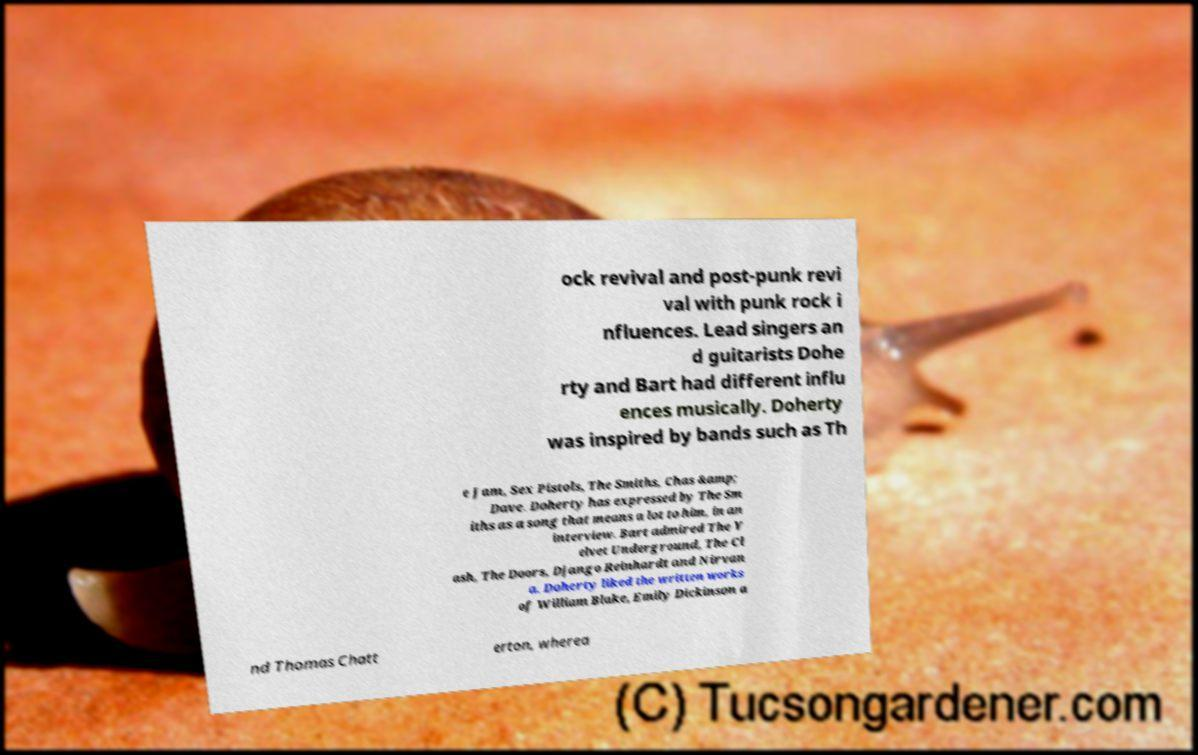What messages or text are displayed in this image? I need them in a readable, typed format. ock revival and post-punk revi val with punk rock i nfluences. Lead singers an d guitarists Dohe rty and Bart had different influ ences musically. Doherty was inspired by bands such as Th e Jam, Sex Pistols, The Smiths, Chas &amp; Dave. Doherty has expressed by The Sm iths as a song that means a lot to him, in an interview. Bart admired The V elvet Underground, The Cl ash, The Doors, Django Reinhardt and Nirvan a. Doherty liked the written works of William Blake, Emily Dickinson a nd Thomas Chatt erton, wherea 